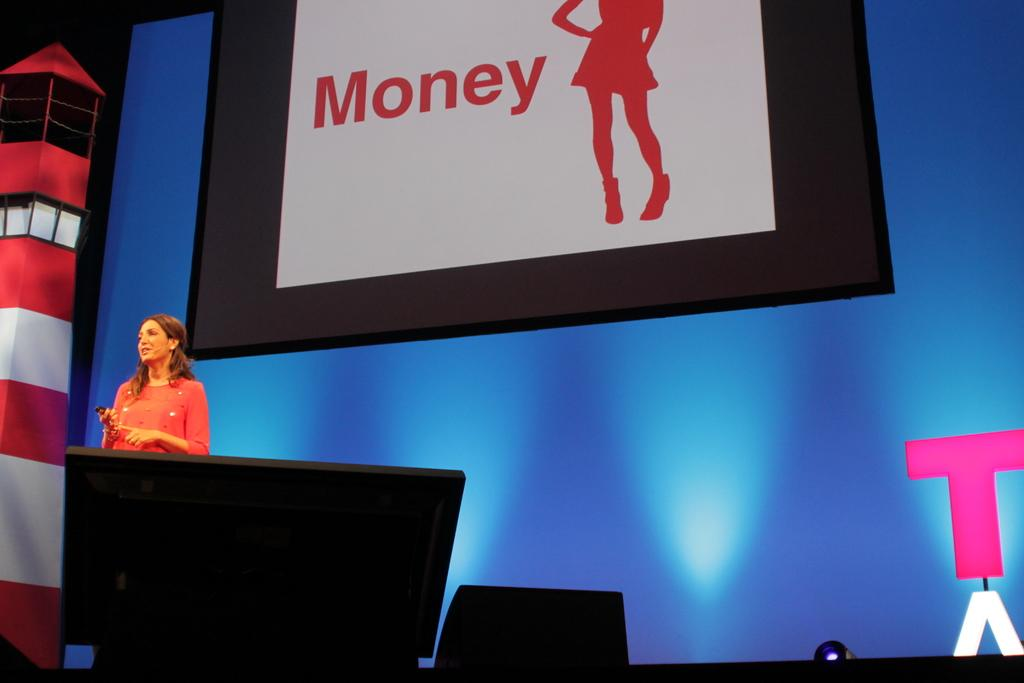Provide a one-sentence caption for the provided image. A sign featuring the word money in red on white. 